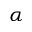<formula> <loc_0><loc_0><loc_500><loc_500>\alpha</formula> 